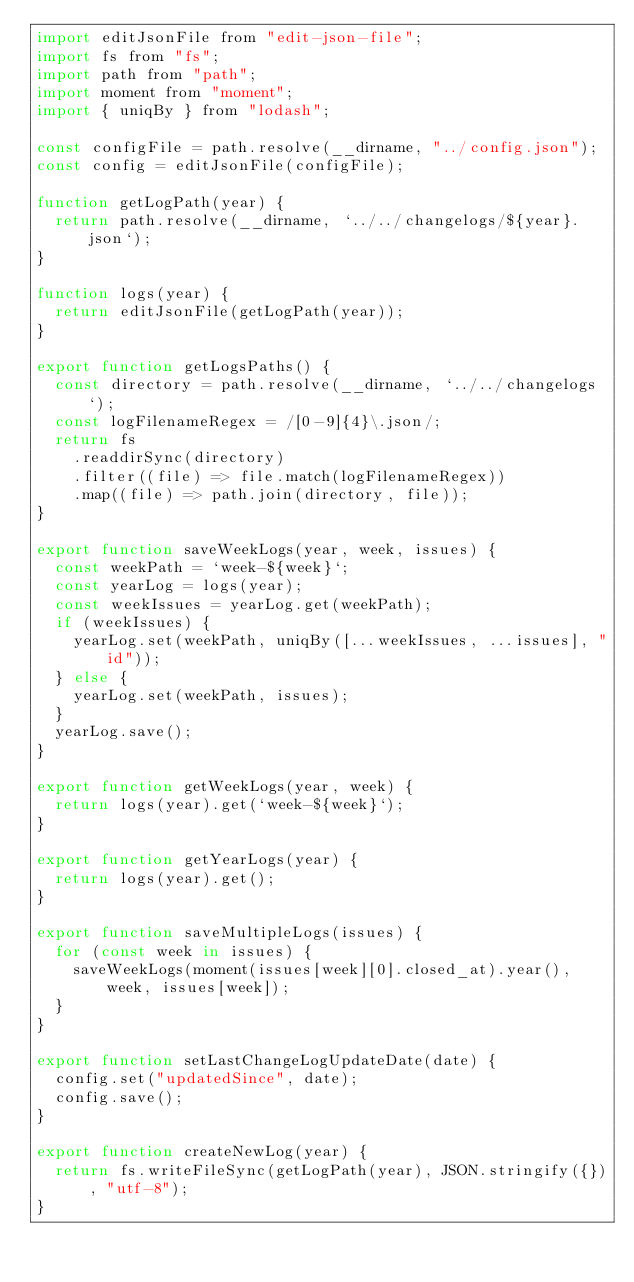<code> <loc_0><loc_0><loc_500><loc_500><_JavaScript_>import editJsonFile from "edit-json-file";
import fs from "fs";
import path from "path";
import moment from "moment";
import { uniqBy } from "lodash";

const configFile = path.resolve(__dirname, "../config.json");
const config = editJsonFile(configFile);

function getLogPath(year) {
  return path.resolve(__dirname, `../../changelogs/${year}.json`);
}

function logs(year) {
  return editJsonFile(getLogPath(year));
}

export function getLogsPaths() {
  const directory = path.resolve(__dirname, `../../changelogs`);
  const logFilenameRegex = /[0-9]{4}\.json/;
  return fs
    .readdirSync(directory)
    .filter((file) => file.match(logFilenameRegex))
    .map((file) => path.join(directory, file));
}

export function saveWeekLogs(year, week, issues) {
  const weekPath = `week-${week}`;
  const yearLog = logs(year);
  const weekIssues = yearLog.get(weekPath);
  if (weekIssues) {
    yearLog.set(weekPath, uniqBy([...weekIssues, ...issues], "id"));
  } else {
    yearLog.set(weekPath, issues);
  }
  yearLog.save();
}

export function getWeekLogs(year, week) {
  return logs(year).get(`week-${week}`);
}

export function getYearLogs(year) {
  return logs(year).get();
}

export function saveMultipleLogs(issues) {
  for (const week in issues) {
    saveWeekLogs(moment(issues[week][0].closed_at).year(), week, issues[week]);
  }
}

export function setLastChangeLogUpdateDate(date) {
  config.set("updatedSince", date);
  config.save();
}

export function createNewLog(year) {
  return fs.writeFileSync(getLogPath(year), JSON.stringify({}), "utf-8");
}
</code> 